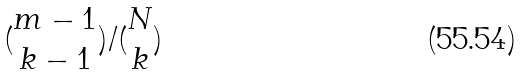Convert formula to latex. <formula><loc_0><loc_0><loc_500><loc_500>( \begin{matrix} m - 1 \\ k - 1 \end{matrix} ) / ( \begin{matrix} N \\ k \end{matrix} )</formula> 